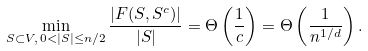Convert formula to latex. <formula><loc_0><loc_0><loc_500><loc_500>\min _ { S \subset V , \, 0 < | S | \leq n / 2 } \frac { | F ( S , S ^ { c } ) | } { | S | } = \Theta \left ( \frac { 1 } { c } \right ) = \Theta \left ( \frac { 1 } { n ^ { 1 / d } } \right ) .</formula> 